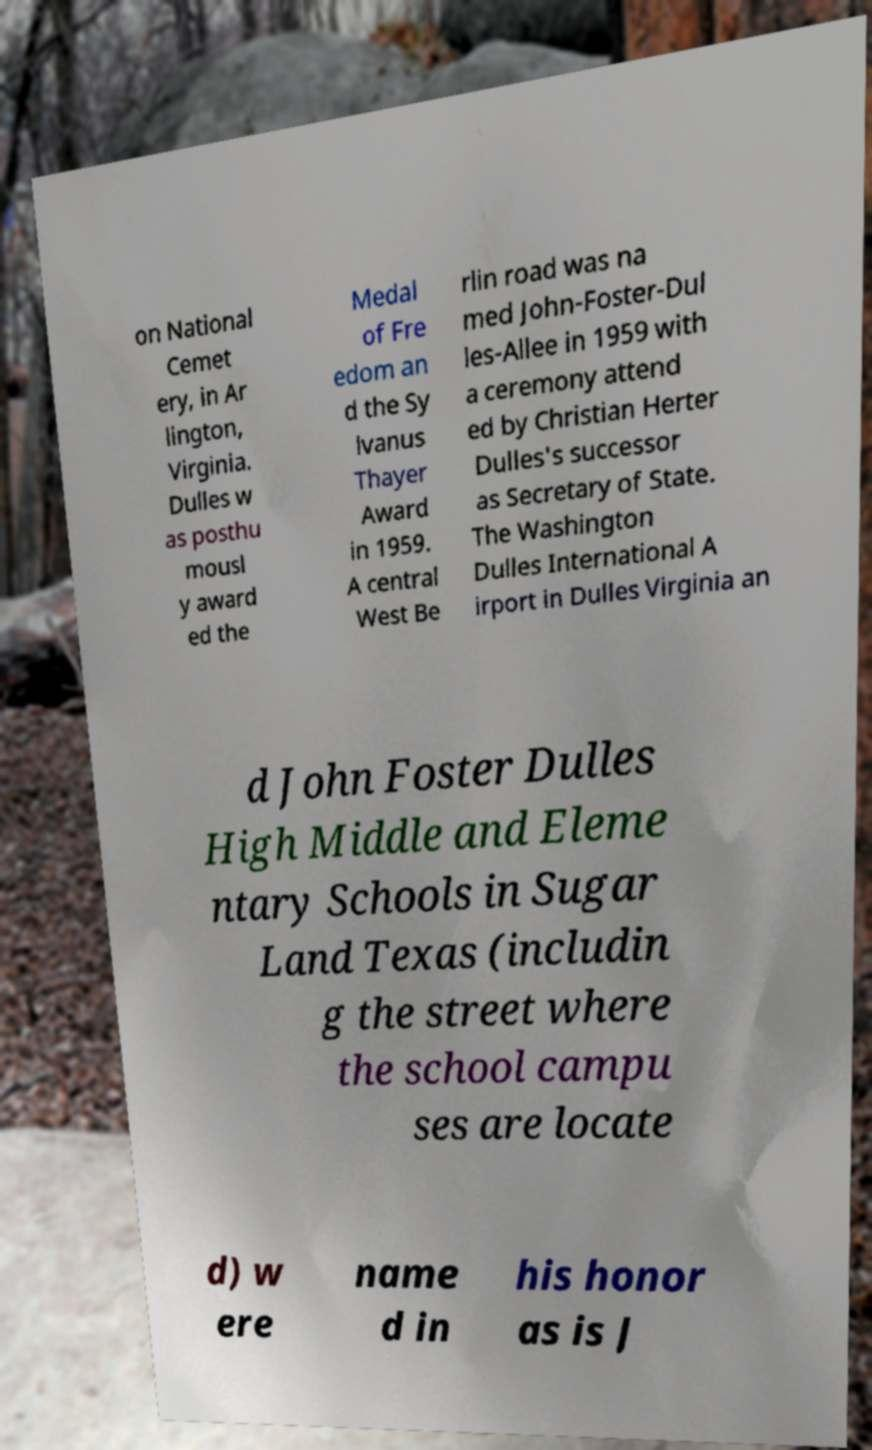Could you assist in decoding the text presented in this image and type it out clearly? on National Cemet ery, in Ar lington, Virginia. Dulles w as posthu mousl y award ed the Medal of Fre edom an d the Sy lvanus Thayer Award in 1959. A central West Be rlin road was na med John-Foster-Dul les-Allee in 1959 with a ceremony attend ed by Christian Herter Dulles's successor as Secretary of State. The Washington Dulles International A irport in Dulles Virginia an d John Foster Dulles High Middle and Eleme ntary Schools in Sugar Land Texas (includin g the street where the school campu ses are locate d) w ere name d in his honor as is J 